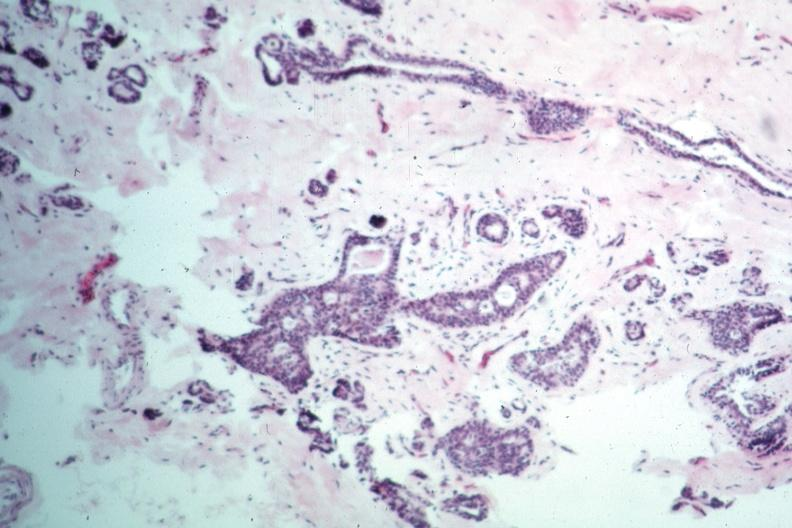s breast present?
Answer the question using a single word or phrase. Yes 